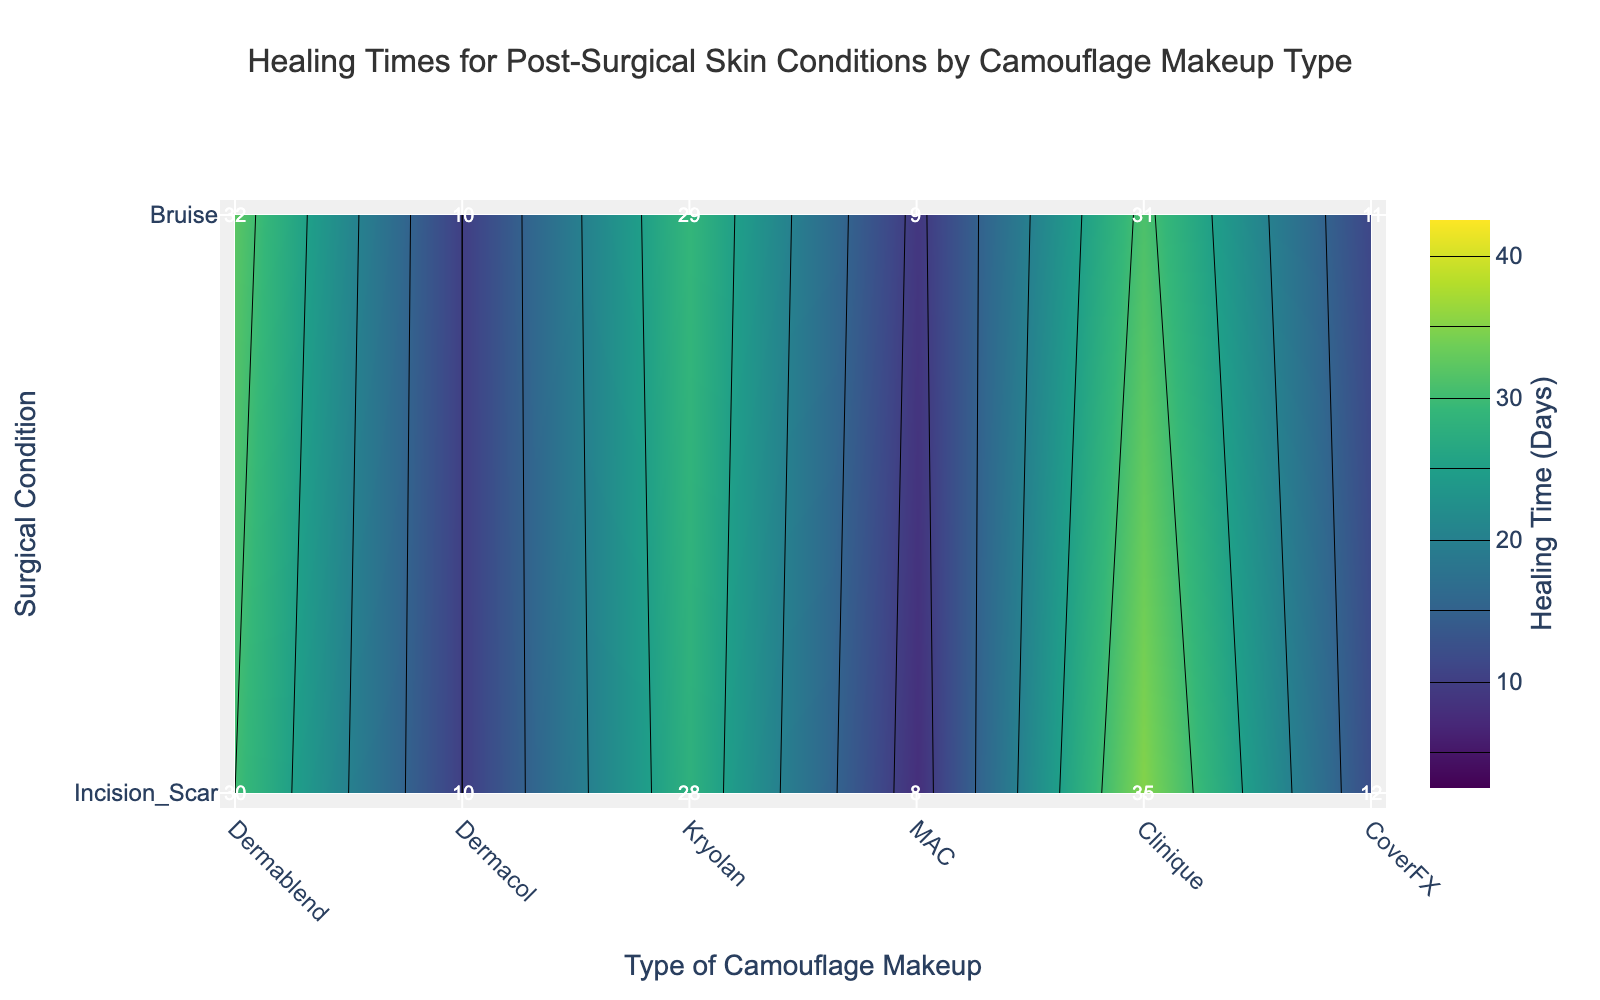What is the title of the contour plot? The title of the plot is typically located at the top. Here, it reads "Healing Times for Post-Surgical Skin Conditions by Camouflage Makeup Type."
Answer: Healing Times for Post-Surgical Skin Conditions by Camouflage Makeup Type Which camouflage makeup type has the shortest healing time for bruises? Look at the contour plot for the lowest value in the 'Bruise' row. The lowest healing time is 8 days, corresponding to Dermacol.
Answer: Dermacol Among the different makeup types, which one shows the longest healing time for incision scars? Find the highest value in the 'Incision Scar' row on the contour plot. Kryolan shows a healing time of 35 days.
Answer: Kryolan What is the difference in Healing Time (Days) for Dermablend makeup between Incision Scar and Bruise? Identify the values for Incision Scar and Bruise for Dermablend. Subtract the healing time for Bruise (10 days) from Incision Scar (30 days): 30 - 10 = 20 days.
Answer: 20 days On average, which surgical condition has a shorter healing time across all makeup types, Incision Scar or Bruise? Calculate the average healing time for each condition. Incision Scar: (30+28+35+32+29+31)/6 = 30.83 days. Bruise: (10+8+12+10+9+11)/6 = 10 days. Bruise healing time is shorter.
Answer: Bruise How many contour levels are depicted in the plot, and what increments do they follow? The contour plot shows lines representing increments from the start to end value. Here, contours start at 5, end at 40, and increment by 5 units.
Answer: 8 levels in increments of 5 Which combination of makeup type and surgical condition has the greatest effectiveness score, and what is the associated healing time? Check individual combinations for the highest effectiveness score. Dermablend with Bruise has an effectiveness score of 90. The healing time for this combination is 10 days.
Answer: Dermablend with Bruise, 10 days What is the healing time for MAC makeup used on a bruise? Look at the point for MAC under the 'Bruise' row in the contour plot; the annotated text shows the healing time of 10 days.
Answer: 10 days 